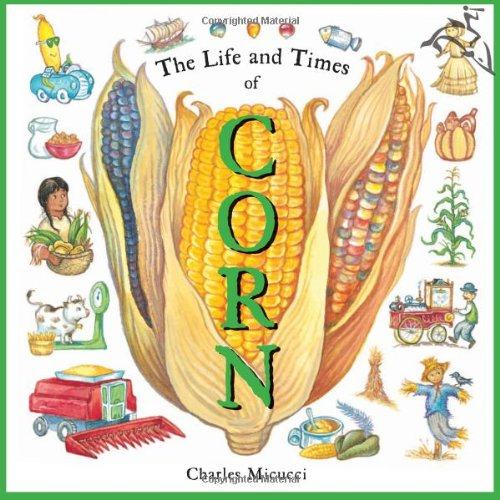What age group would benefit most from reading this book? Children aged between 5 and 12 years would find this book particularly beneficial. It presents information in a fun, colorful way that is suitable for young learners. 